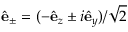Convert formula to latex. <formula><loc_0><loc_0><loc_500><loc_500>\hat { e } _ { \pm } = ( - \hat { e } _ { z } \pm i \hat { e } _ { y } ) / \sqrt { 2 }</formula> 